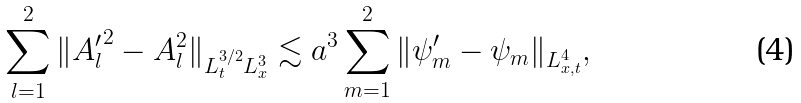Convert formula to latex. <formula><loc_0><loc_0><loc_500><loc_500>\sum _ { l = 1 } ^ { 2 } \| { A ^ { \prime } _ { l } } ^ { 2 } - A _ { l } ^ { 2 } \| _ { L ^ { 3 / 2 } _ { t } L ^ { 3 } _ { x } } \lesssim a ^ { 3 } \sum _ { m = 1 } ^ { 2 } \| \psi ^ { \prime } _ { m } - \psi _ { m } \| _ { L ^ { 4 } _ { x , t } } ,</formula> 